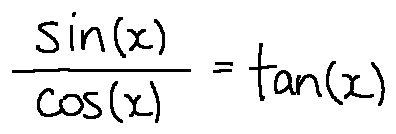<formula> <loc_0><loc_0><loc_500><loc_500>\frac { \sin ( x ) } { \cos ( x ) } = \tan ( x )</formula> 